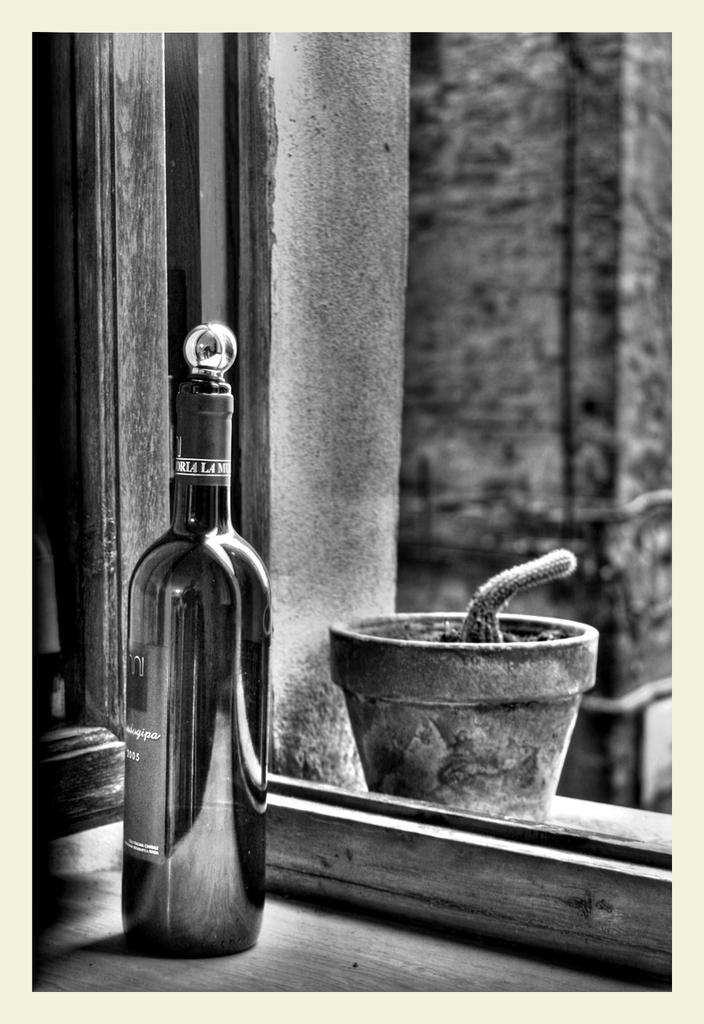What is featured on the poster in the image? The poster contains objects, including a bottle and a pot. What else can be seen in the image besides the poster? There is a wall visible in the image. How does the book on the poster twist in the air? There is no book present on the poster, and therefore no such activity can be observed. 